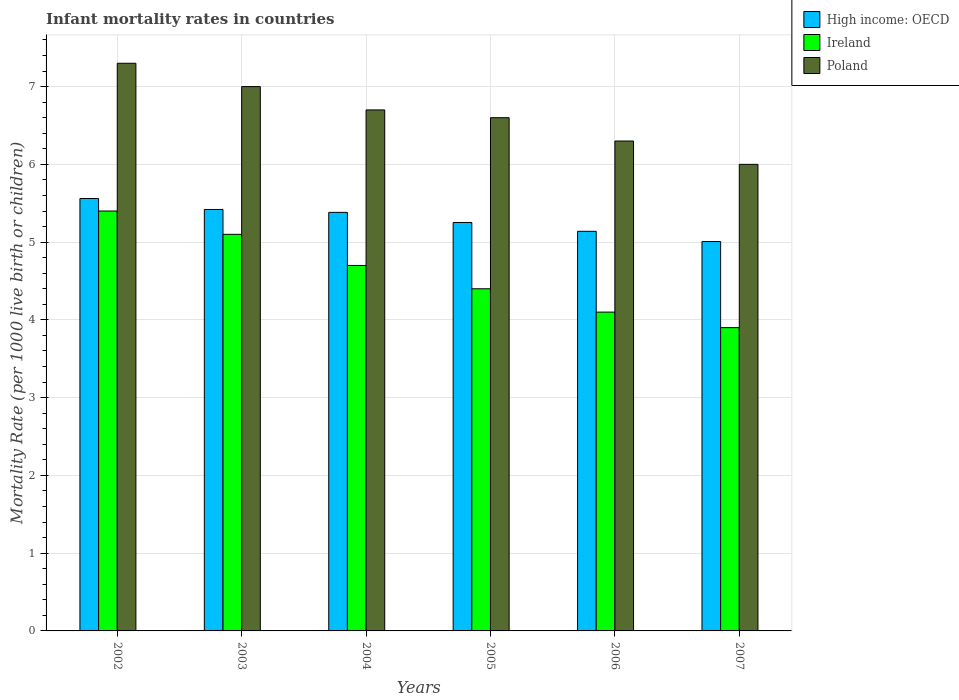How many different coloured bars are there?
Offer a very short reply. 3. Are the number of bars per tick equal to the number of legend labels?
Your response must be concise. Yes. In how many cases, is the number of bars for a given year not equal to the number of legend labels?
Give a very brief answer. 0. Across all years, what is the maximum infant mortality rate in Ireland?
Your answer should be very brief. 5.4. Across all years, what is the minimum infant mortality rate in High income: OECD?
Give a very brief answer. 5.01. In which year was the infant mortality rate in Ireland minimum?
Provide a short and direct response. 2007. What is the total infant mortality rate in Poland in the graph?
Offer a very short reply. 39.9. What is the difference between the infant mortality rate in High income: OECD in 2002 and that in 2004?
Ensure brevity in your answer.  0.18. What is the difference between the infant mortality rate in Ireland in 2005 and the infant mortality rate in High income: OECD in 2006?
Your answer should be very brief. -0.74. What is the average infant mortality rate in Poland per year?
Offer a very short reply. 6.65. In the year 2007, what is the difference between the infant mortality rate in High income: OECD and infant mortality rate in Ireland?
Make the answer very short. 1.11. In how many years, is the infant mortality rate in Poland greater than 3.6?
Your answer should be very brief. 6. What is the ratio of the infant mortality rate in High income: OECD in 2002 to that in 2005?
Your answer should be very brief. 1.06. Is the infant mortality rate in Ireland in 2004 less than that in 2006?
Make the answer very short. No. What is the difference between the highest and the second highest infant mortality rate in Poland?
Keep it short and to the point. 0.3. What is the difference between the highest and the lowest infant mortality rate in High income: OECD?
Your answer should be compact. 0.55. In how many years, is the infant mortality rate in High income: OECD greater than the average infant mortality rate in High income: OECD taken over all years?
Provide a succinct answer. 3. Is the sum of the infant mortality rate in Ireland in 2002 and 2004 greater than the maximum infant mortality rate in High income: OECD across all years?
Your answer should be compact. Yes. What does the 2nd bar from the right in 2002 represents?
Provide a succinct answer. Ireland. Is it the case that in every year, the sum of the infant mortality rate in Ireland and infant mortality rate in High income: OECD is greater than the infant mortality rate in Poland?
Give a very brief answer. Yes. How many bars are there?
Keep it short and to the point. 18. Are all the bars in the graph horizontal?
Provide a short and direct response. No. Does the graph contain grids?
Offer a terse response. Yes. How many legend labels are there?
Give a very brief answer. 3. How are the legend labels stacked?
Give a very brief answer. Vertical. What is the title of the graph?
Make the answer very short. Infant mortality rates in countries. Does "Uganda" appear as one of the legend labels in the graph?
Keep it short and to the point. No. What is the label or title of the X-axis?
Give a very brief answer. Years. What is the label or title of the Y-axis?
Provide a short and direct response. Mortality Rate (per 1000 live birth or children). What is the Mortality Rate (per 1000 live birth or children) of High income: OECD in 2002?
Give a very brief answer. 5.56. What is the Mortality Rate (per 1000 live birth or children) in Poland in 2002?
Ensure brevity in your answer.  7.3. What is the Mortality Rate (per 1000 live birth or children) in High income: OECD in 2003?
Your answer should be compact. 5.42. What is the Mortality Rate (per 1000 live birth or children) in Poland in 2003?
Offer a terse response. 7. What is the Mortality Rate (per 1000 live birth or children) in High income: OECD in 2004?
Provide a short and direct response. 5.38. What is the Mortality Rate (per 1000 live birth or children) in Ireland in 2004?
Your answer should be very brief. 4.7. What is the Mortality Rate (per 1000 live birth or children) of Poland in 2004?
Offer a very short reply. 6.7. What is the Mortality Rate (per 1000 live birth or children) of High income: OECD in 2005?
Provide a short and direct response. 5.25. What is the Mortality Rate (per 1000 live birth or children) in High income: OECD in 2006?
Make the answer very short. 5.14. What is the Mortality Rate (per 1000 live birth or children) in Ireland in 2006?
Your answer should be compact. 4.1. What is the Mortality Rate (per 1000 live birth or children) of High income: OECD in 2007?
Offer a terse response. 5.01. What is the Mortality Rate (per 1000 live birth or children) of Poland in 2007?
Keep it short and to the point. 6. Across all years, what is the maximum Mortality Rate (per 1000 live birth or children) in High income: OECD?
Your answer should be very brief. 5.56. Across all years, what is the maximum Mortality Rate (per 1000 live birth or children) of Ireland?
Keep it short and to the point. 5.4. Across all years, what is the maximum Mortality Rate (per 1000 live birth or children) in Poland?
Offer a terse response. 7.3. Across all years, what is the minimum Mortality Rate (per 1000 live birth or children) in High income: OECD?
Ensure brevity in your answer.  5.01. What is the total Mortality Rate (per 1000 live birth or children) of High income: OECD in the graph?
Your response must be concise. 31.76. What is the total Mortality Rate (per 1000 live birth or children) in Ireland in the graph?
Provide a short and direct response. 27.6. What is the total Mortality Rate (per 1000 live birth or children) of Poland in the graph?
Provide a short and direct response. 39.9. What is the difference between the Mortality Rate (per 1000 live birth or children) in High income: OECD in 2002 and that in 2003?
Provide a succinct answer. 0.14. What is the difference between the Mortality Rate (per 1000 live birth or children) of High income: OECD in 2002 and that in 2004?
Give a very brief answer. 0.18. What is the difference between the Mortality Rate (per 1000 live birth or children) of Ireland in 2002 and that in 2004?
Your answer should be very brief. 0.7. What is the difference between the Mortality Rate (per 1000 live birth or children) in Poland in 2002 and that in 2004?
Keep it short and to the point. 0.6. What is the difference between the Mortality Rate (per 1000 live birth or children) of High income: OECD in 2002 and that in 2005?
Give a very brief answer. 0.31. What is the difference between the Mortality Rate (per 1000 live birth or children) of Ireland in 2002 and that in 2005?
Provide a short and direct response. 1. What is the difference between the Mortality Rate (per 1000 live birth or children) of High income: OECD in 2002 and that in 2006?
Your response must be concise. 0.42. What is the difference between the Mortality Rate (per 1000 live birth or children) of Poland in 2002 and that in 2006?
Make the answer very short. 1. What is the difference between the Mortality Rate (per 1000 live birth or children) in High income: OECD in 2002 and that in 2007?
Your answer should be compact. 0.55. What is the difference between the Mortality Rate (per 1000 live birth or children) of High income: OECD in 2003 and that in 2004?
Provide a succinct answer. 0.04. What is the difference between the Mortality Rate (per 1000 live birth or children) in Ireland in 2003 and that in 2004?
Make the answer very short. 0.4. What is the difference between the Mortality Rate (per 1000 live birth or children) of High income: OECD in 2003 and that in 2005?
Offer a very short reply. 0.17. What is the difference between the Mortality Rate (per 1000 live birth or children) of Ireland in 2003 and that in 2005?
Offer a terse response. 0.7. What is the difference between the Mortality Rate (per 1000 live birth or children) of Poland in 2003 and that in 2005?
Provide a succinct answer. 0.4. What is the difference between the Mortality Rate (per 1000 live birth or children) of High income: OECD in 2003 and that in 2006?
Offer a terse response. 0.28. What is the difference between the Mortality Rate (per 1000 live birth or children) of High income: OECD in 2003 and that in 2007?
Keep it short and to the point. 0.41. What is the difference between the Mortality Rate (per 1000 live birth or children) in Ireland in 2003 and that in 2007?
Your answer should be compact. 1.2. What is the difference between the Mortality Rate (per 1000 live birth or children) of Poland in 2003 and that in 2007?
Provide a succinct answer. 1. What is the difference between the Mortality Rate (per 1000 live birth or children) of High income: OECD in 2004 and that in 2005?
Offer a terse response. 0.13. What is the difference between the Mortality Rate (per 1000 live birth or children) in High income: OECD in 2004 and that in 2006?
Ensure brevity in your answer.  0.24. What is the difference between the Mortality Rate (per 1000 live birth or children) in High income: OECD in 2004 and that in 2007?
Ensure brevity in your answer.  0.38. What is the difference between the Mortality Rate (per 1000 live birth or children) in High income: OECD in 2005 and that in 2006?
Your answer should be very brief. 0.11. What is the difference between the Mortality Rate (per 1000 live birth or children) of Poland in 2005 and that in 2006?
Your answer should be compact. 0.3. What is the difference between the Mortality Rate (per 1000 live birth or children) of High income: OECD in 2005 and that in 2007?
Make the answer very short. 0.25. What is the difference between the Mortality Rate (per 1000 live birth or children) in Poland in 2005 and that in 2007?
Make the answer very short. 0.6. What is the difference between the Mortality Rate (per 1000 live birth or children) in High income: OECD in 2006 and that in 2007?
Your answer should be very brief. 0.13. What is the difference between the Mortality Rate (per 1000 live birth or children) in Poland in 2006 and that in 2007?
Your answer should be very brief. 0.3. What is the difference between the Mortality Rate (per 1000 live birth or children) in High income: OECD in 2002 and the Mortality Rate (per 1000 live birth or children) in Ireland in 2003?
Keep it short and to the point. 0.46. What is the difference between the Mortality Rate (per 1000 live birth or children) in High income: OECD in 2002 and the Mortality Rate (per 1000 live birth or children) in Poland in 2003?
Keep it short and to the point. -1.44. What is the difference between the Mortality Rate (per 1000 live birth or children) in High income: OECD in 2002 and the Mortality Rate (per 1000 live birth or children) in Ireland in 2004?
Your answer should be compact. 0.86. What is the difference between the Mortality Rate (per 1000 live birth or children) in High income: OECD in 2002 and the Mortality Rate (per 1000 live birth or children) in Poland in 2004?
Offer a very short reply. -1.14. What is the difference between the Mortality Rate (per 1000 live birth or children) in High income: OECD in 2002 and the Mortality Rate (per 1000 live birth or children) in Ireland in 2005?
Keep it short and to the point. 1.16. What is the difference between the Mortality Rate (per 1000 live birth or children) in High income: OECD in 2002 and the Mortality Rate (per 1000 live birth or children) in Poland in 2005?
Your answer should be compact. -1.04. What is the difference between the Mortality Rate (per 1000 live birth or children) in High income: OECD in 2002 and the Mortality Rate (per 1000 live birth or children) in Ireland in 2006?
Your answer should be compact. 1.46. What is the difference between the Mortality Rate (per 1000 live birth or children) in High income: OECD in 2002 and the Mortality Rate (per 1000 live birth or children) in Poland in 2006?
Make the answer very short. -0.74. What is the difference between the Mortality Rate (per 1000 live birth or children) of Ireland in 2002 and the Mortality Rate (per 1000 live birth or children) of Poland in 2006?
Your response must be concise. -0.9. What is the difference between the Mortality Rate (per 1000 live birth or children) of High income: OECD in 2002 and the Mortality Rate (per 1000 live birth or children) of Ireland in 2007?
Offer a very short reply. 1.66. What is the difference between the Mortality Rate (per 1000 live birth or children) in High income: OECD in 2002 and the Mortality Rate (per 1000 live birth or children) in Poland in 2007?
Give a very brief answer. -0.44. What is the difference between the Mortality Rate (per 1000 live birth or children) in Ireland in 2002 and the Mortality Rate (per 1000 live birth or children) in Poland in 2007?
Your response must be concise. -0.6. What is the difference between the Mortality Rate (per 1000 live birth or children) of High income: OECD in 2003 and the Mortality Rate (per 1000 live birth or children) of Ireland in 2004?
Give a very brief answer. 0.72. What is the difference between the Mortality Rate (per 1000 live birth or children) in High income: OECD in 2003 and the Mortality Rate (per 1000 live birth or children) in Poland in 2004?
Offer a very short reply. -1.28. What is the difference between the Mortality Rate (per 1000 live birth or children) in Ireland in 2003 and the Mortality Rate (per 1000 live birth or children) in Poland in 2004?
Give a very brief answer. -1.6. What is the difference between the Mortality Rate (per 1000 live birth or children) in High income: OECD in 2003 and the Mortality Rate (per 1000 live birth or children) in Ireland in 2005?
Make the answer very short. 1.02. What is the difference between the Mortality Rate (per 1000 live birth or children) in High income: OECD in 2003 and the Mortality Rate (per 1000 live birth or children) in Poland in 2005?
Make the answer very short. -1.18. What is the difference between the Mortality Rate (per 1000 live birth or children) in High income: OECD in 2003 and the Mortality Rate (per 1000 live birth or children) in Ireland in 2006?
Give a very brief answer. 1.32. What is the difference between the Mortality Rate (per 1000 live birth or children) in High income: OECD in 2003 and the Mortality Rate (per 1000 live birth or children) in Poland in 2006?
Keep it short and to the point. -0.88. What is the difference between the Mortality Rate (per 1000 live birth or children) in High income: OECD in 2003 and the Mortality Rate (per 1000 live birth or children) in Ireland in 2007?
Make the answer very short. 1.52. What is the difference between the Mortality Rate (per 1000 live birth or children) of High income: OECD in 2003 and the Mortality Rate (per 1000 live birth or children) of Poland in 2007?
Keep it short and to the point. -0.58. What is the difference between the Mortality Rate (per 1000 live birth or children) of High income: OECD in 2004 and the Mortality Rate (per 1000 live birth or children) of Ireland in 2005?
Ensure brevity in your answer.  0.98. What is the difference between the Mortality Rate (per 1000 live birth or children) in High income: OECD in 2004 and the Mortality Rate (per 1000 live birth or children) in Poland in 2005?
Provide a short and direct response. -1.22. What is the difference between the Mortality Rate (per 1000 live birth or children) in Ireland in 2004 and the Mortality Rate (per 1000 live birth or children) in Poland in 2005?
Your answer should be very brief. -1.9. What is the difference between the Mortality Rate (per 1000 live birth or children) of High income: OECD in 2004 and the Mortality Rate (per 1000 live birth or children) of Ireland in 2006?
Ensure brevity in your answer.  1.28. What is the difference between the Mortality Rate (per 1000 live birth or children) of High income: OECD in 2004 and the Mortality Rate (per 1000 live birth or children) of Poland in 2006?
Offer a terse response. -0.92. What is the difference between the Mortality Rate (per 1000 live birth or children) of Ireland in 2004 and the Mortality Rate (per 1000 live birth or children) of Poland in 2006?
Your response must be concise. -1.6. What is the difference between the Mortality Rate (per 1000 live birth or children) of High income: OECD in 2004 and the Mortality Rate (per 1000 live birth or children) of Ireland in 2007?
Your answer should be very brief. 1.48. What is the difference between the Mortality Rate (per 1000 live birth or children) of High income: OECD in 2004 and the Mortality Rate (per 1000 live birth or children) of Poland in 2007?
Ensure brevity in your answer.  -0.62. What is the difference between the Mortality Rate (per 1000 live birth or children) in High income: OECD in 2005 and the Mortality Rate (per 1000 live birth or children) in Ireland in 2006?
Keep it short and to the point. 1.15. What is the difference between the Mortality Rate (per 1000 live birth or children) of High income: OECD in 2005 and the Mortality Rate (per 1000 live birth or children) of Poland in 2006?
Your response must be concise. -1.05. What is the difference between the Mortality Rate (per 1000 live birth or children) in Ireland in 2005 and the Mortality Rate (per 1000 live birth or children) in Poland in 2006?
Provide a succinct answer. -1.9. What is the difference between the Mortality Rate (per 1000 live birth or children) of High income: OECD in 2005 and the Mortality Rate (per 1000 live birth or children) of Ireland in 2007?
Offer a very short reply. 1.35. What is the difference between the Mortality Rate (per 1000 live birth or children) in High income: OECD in 2005 and the Mortality Rate (per 1000 live birth or children) in Poland in 2007?
Your response must be concise. -0.75. What is the difference between the Mortality Rate (per 1000 live birth or children) of Ireland in 2005 and the Mortality Rate (per 1000 live birth or children) of Poland in 2007?
Offer a very short reply. -1.6. What is the difference between the Mortality Rate (per 1000 live birth or children) of High income: OECD in 2006 and the Mortality Rate (per 1000 live birth or children) of Ireland in 2007?
Provide a short and direct response. 1.24. What is the difference between the Mortality Rate (per 1000 live birth or children) of High income: OECD in 2006 and the Mortality Rate (per 1000 live birth or children) of Poland in 2007?
Provide a short and direct response. -0.86. What is the average Mortality Rate (per 1000 live birth or children) of High income: OECD per year?
Provide a short and direct response. 5.29. What is the average Mortality Rate (per 1000 live birth or children) of Poland per year?
Make the answer very short. 6.65. In the year 2002, what is the difference between the Mortality Rate (per 1000 live birth or children) of High income: OECD and Mortality Rate (per 1000 live birth or children) of Ireland?
Keep it short and to the point. 0.16. In the year 2002, what is the difference between the Mortality Rate (per 1000 live birth or children) in High income: OECD and Mortality Rate (per 1000 live birth or children) in Poland?
Keep it short and to the point. -1.74. In the year 2003, what is the difference between the Mortality Rate (per 1000 live birth or children) of High income: OECD and Mortality Rate (per 1000 live birth or children) of Ireland?
Offer a terse response. 0.32. In the year 2003, what is the difference between the Mortality Rate (per 1000 live birth or children) of High income: OECD and Mortality Rate (per 1000 live birth or children) of Poland?
Your response must be concise. -1.58. In the year 2004, what is the difference between the Mortality Rate (per 1000 live birth or children) of High income: OECD and Mortality Rate (per 1000 live birth or children) of Ireland?
Ensure brevity in your answer.  0.68. In the year 2004, what is the difference between the Mortality Rate (per 1000 live birth or children) in High income: OECD and Mortality Rate (per 1000 live birth or children) in Poland?
Offer a very short reply. -1.32. In the year 2004, what is the difference between the Mortality Rate (per 1000 live birth or children) of Ireland and Mortality Rate (per 1000 live birth or children) of Poland?
Offer a very short reply. -2. In the year 2005, what is the difference between the Mortality Rate (per 1000 live birth or children) in High income: OECD and Mortality Rate (per 1000 live birth or children) in Ireland?
Keep it short and to the point. 0.85. In the year 2005, what is the difference between the Mortality Rate (per 1000 live birth or children) of High income: OECD and Mortality Rate (per 1000 live birth or children) of Poland?
Ensure brevity in your answer.  -1.35. In the year 2005, what is the difference between the Mortality Rate (per 1000 live birth or children) of Ireland and Mortality Rate (per 1000 live birth or children) of Poland?
Your response must be concise. -2.2. In the year 2006, what is the difference between the Mortality Rate (per 1000 live birth or children) in High income: OECD and Mortality Rate (per 1000 live birth or children) in Ireland?
Your answer should be compact. 1.04. In the year 2006, what is the difference between the Mortality Rate (per 1000 live birth or children) in High income: OECD and Mortality Rate (per 1000 live birth or children) in Poland?
Give a very brief answer. -1.16. In the year 2007, what is the difference between the Mortality Rate (per 1000 live birth or children) in High income: OECD and Mortality Rate (per 1000 live birth or children) in Ireland?
Your answer should be compact. 1.11. In the year 2007, what is the difference between the Mortality Rate (per 1000 live birth or children) of High income: OECD and Mortality Rate (per 1000 live birth or children) of Poland?
Give a very brief answer. -0.99. What is the ratio of the Mortality Rate (per 1000 live birth or children) in High income: OECD in 2002 to that in 2003?
Your response must be concise. 1.03. What is the ratio of the Mortality Rate (per 1000 live birth or children) in Ireland in 2002 to that in 2003?
Keep it short and to the point. 1.06. What is the ratio of the Mortality Rate (per 1000 live birth or children) in Poland in 2002 to that in 2003?
Keep it short and to the point. 1.04. What is the ratio of the Mortality Rate (per 1000 live birth or children) in High income: OECD in 2002 to that in 2004?
Your response must be concise. 1.03. What is the ratio of the Mortality Rate (per 1000 live birth or children) in Ireland in 2002 to that in 2004?
Your response must be concise. 1.15. What is the ratio of the Mortality Rate (per 1000 live birth or children) of Poland in 2002 to that in 2004?
Your answer should be very brief. 1.09. What is the ratio of the Mortality Rate (per 1000 live birth or children) in High income: OECD in 2002 to that in 2005?
Offer a terse response. 1.06. What is the ratio of the Mortality Rate (per 1000 live birth or children) in Ireland in 2002 to that in 2005?
Provide a short and direct response. 1.23. What is the ratio of the Mortality Rate (per 1000 live birth or children) of Poland in 2002 to that in 2005?
Your answer should be compact. 1.11. What is the ratio of the Mortality Rate (per 1000 live birth or children) of High income: OECD in 2002 to that in 2006?
Ensure brevity in your answer.  1.08. What is the ratio of the Mortality Rate (per 1000 live birth or children) of Ireland in 2002 to that in 2006?
Your answer should be very brief. 1.32. What is the ratio of the Mortality Rate (per 1000 live birth or children) of Poland in 2002 to that in 2006?
Ensure brevity in your answer.  1.16. What is the ratio of the Mortality Rate (per 1000 live birth or children) in High income: OECD in 2002 to that in 2007?
Make the answer very short. 1.11. What is the ratio of the Mortality Rate (per 1000 live birth or children) in Ireland in 2002 to that in 2007?
Offer a terse response. 1.38. What is the ratio of the Mortality Rate (per 1000 live birth or children) in Poland in 2002 to that in 2007?
Offer a very short reply. 1.22. What is the ratio of the Mortality Rate (per 1000 live birth or children) of High income: OECD in 2003 to that in 2004?
Your answer should be very brief. 1.01. What is the ratio of the Mortality Rate (per 1000 live birth or children) of Ireland in 2003 to that in 2004?
Provide a succinct answer. 1.09. What is the ratio of the Mortality Rate (per 1000 live birth or children) of Poland in 2003 to that in 2004?
Make the answer very short. 1.04. What is the ratio of the Mortality Rate (per 1000 live birth or children) of High income: OECD in 2003 to that in 2005?
Ensure brevity in your answer.  1.03. What is the ratio of the Mortality Rate (per 1000 live birth or children) in Ireland in 2003 to that in 2005?
Make the answer very short. 1.16. What is the ratio of the Mortality Rate (per 1000 live birth or children) of Poland in 2003 to that in 2005?
Your response must be concise. 1.06. What is the ratio of the Mortality Rate (per 1000 live birth or children) in High income: OECD in 2003 to that in 2006?
Offer a terse response. 1.05. What is the ratio of the Mortality Rate (per 1000 live birth or children) in Ireland in 2003 to that in 2006?
Offer a terse response. 1.24. What is the ratio of the Mortality Rate (per 1000 live birth or children) of High income: OECD in 2003 to that in 2007?
Provide a short and direct response. 1.08. What is the ratio of the Mortality Rate (per 1000 live birth or children) of Ireland in 2003 to that in 2007?
Keep it short and to the point. 1.31. What is the ratio of the Mortality Rate (per 1000 live birth or children) in High income: OECD in 2004 to that in 2005?
Provide a succinct answer. 1.02. What is the ratio of the Mortality Rate (per 1000 live birth or children) in Ireland in 2004 to that in 2005?
Keep it short and to the point. 1.07. What is the ratio of the Mortality Rate (per 1000 live birth or children) of Poland in 2004 to that in 2005?
Provide a succinct answer. 1.02. What is the ratio of the Mortality Rate (per 1000 live birth or children) of High income: OECD in 2004 to that in 2006?
Give a very brief answer. 1.05. What is the ratio of the Mortality Rate (per 1000 live birth or children) of Ireland in 2004 to that in 2006?
Your answer should be very brief. 1.15. What is the ratio of the Mortality Rate (per 1000 live birth or children) in Poland in 2004 to that in 2006?
Provide a succinct answer. 1.06. What is the ratio of the Mortality Rate (per 1000 live birth or children) in High income: OECD in 2004 to that in 2007?
Make the answer very short. 1.07. What is the ratio of the Mortality Rate (per 1000 live birth or children) of Ireland in 2004 to that in 2007?
Offer a terse response. 1.21. What is the ratio of the Mortality Rate (per 1000 live birth or children) of Poland in 2004 to that in 2007?
Keep it short and to the point. 1.12. What is the ratio of the Mortality Rate (per 1000 live birth or children) in High income: OECD in 2005 to that in 2006?
Make the answer very short. 1.02. What is the ratio of the Mortality Rate (per 1000 live birth or children) of Ireland in 2005 to that in 2006?
Make the answer very short. 1.07. What is the ratio of the Mortality Rate (per 1000 live birth or children) of Poland in 2005 to that in 2006?
Give a very brief answer. 1.05. What is the ratio of the Mortality Rate (per 1000 live birth or children) in High income: OECD in 2005 to that in 2007?
Give a very brief answer. 1.05. What is the ratio of the Mortality Rate (per 1000 live birth or children) of Ireland in 2005 to that in 2007?
Your answer should be compact. 1.13. What is the ratio of the Mortality Rate (per 1000 live birth or children) in High income: OECD in 2006 to that in 2007?
Your answer should be very brief. 1.03. What is the ratio of the Mortality Rate (per 1000 live birth or children) in Ireland in 2006 to that in 2007?
Provide a succinct answer. 1.05. What is the ratio of the Mortality Rate (per 1000 live birth or children) of Poland in 2006 to that in 2007?
Give a very brief answer. 1.05. What is the difference between the highest and the second highest Mortality Rate (per 1000 live birth or children) of High income: OECD?
Your answer should be compact. 0.14. What is the difference between the highest and the second highest Mortality Rate (per 1000 live birth or children) of Poland?
Your response must be concise. 0.3. What is the difference between the highest and the lowest Mortality Rate (per 1000 live birth or children) in High income: OECD?
Provide a short and direct response. 0.55. What is the difference between the highest and the lowest Mortality Rate (per 1000 live birth or children) in Poland?
Your answer should be very brief. 1.3. 